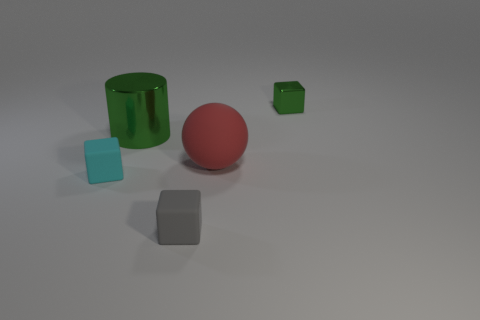Are there any small shiny cubes that have the same color as the large shiny thing?
Offer a terse response. Yes. Are there any big gray spheres?
Give a very brief answer. No. The green object right of the big green shiny object has what shape?
Offer a very short reply. Cube. What number of things are both on the left side of the red thing and in front of the metallic cylinder?
Your answer should be compact. 2. What number of other things are the same size as the red thing?
Offer a terse response. 1. There is a metal thing that is on the right side of the large green shiny thing; is it the same shape as the tiny matte object behind the gray cube?
Your answer should be compact. Yes. What number of objects are either large red spheres or cylinders behind the small cyan object?
Provide a short and direct response. 2. There is a small object that is right of the green cylinder and in front of the shiny cube; what material is it made of?
Ensure brevity in your answer.  Rubber. Are there any other things that have the same shape as the large red matte thing?
Provide a short and direct response. No. What is the color of the ball that is the same material as the cyan cube?
Offer a terse response. Red. 